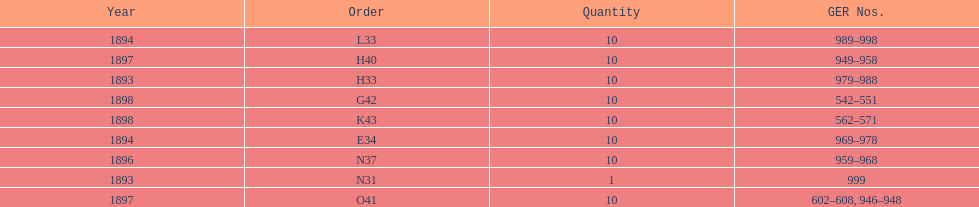Was the amount greater in 1894 or 1893? 1894. 